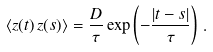Convert formula to latex. <formula><loc_0><loc_0><loc_500><loc_500>\langle z ( t ) \, z ( s ) \rangle = \frac { D } { \tau } \exp \left ( - \frac { | t - s | } { \tau } \right ) \, .</formula> 